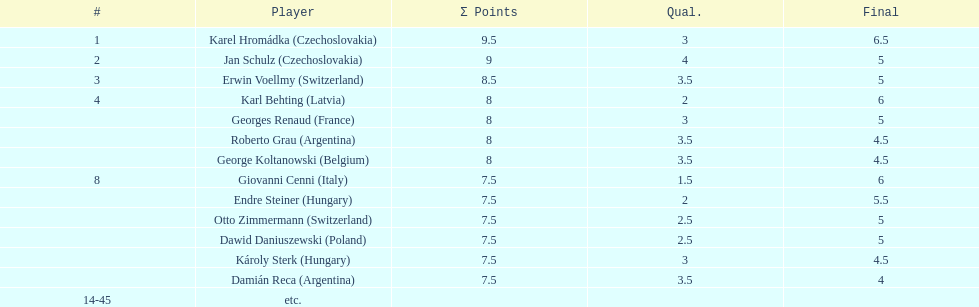What were the final scores of karl behting and giovanni cenni each? 6. Can you give me this table as a dict? {'header': ['#', 'Player', 'Σ Points', 'Qual.', 'Final'], 'rows': [['1', 'Karel Hromádka\xa0(Czechoslovakia)', '9.5', '3', '6.5'], ['2', 'Jan Schulz\xa0(Czechoslovakia)', '9', '4', '5'], ['3', 'Erwin Voellmy\xa0(Switzerland)', '8.5', '3.5', '5'], ['4', 'Karl Behting\xa0(Latvia)', '8', '2', '6'], ['', 'Georges Renaud\xa0(France)', '8', '3', '5'], ['', 'Roberto Grau\xa0(Argentina)', '8', '3.5', '4.5'], ['', 'George Koltanowski\xa0(Belgium)', '8', '3.5', '4.5'], ['8', 'Giovanni Cenni\xa0(Italy)', '7.5', '1.5', '6'], ['', 'Endre Steiner\xa0(Hungary)', '7.5', '2', '5.5'], ['', 'Otto Zimmermann\xa0(Switzerland)', '7.5', '2.5', '5'], ['', 'Dawid Daniuszewski\xa0(Poland)', '7.5', '2.5', '5'], ['', 'Károly Sterk\xa0(Hungary)', '7.5', '3', '4.5'], ['', 'Damián Reca\xa0(Argentina)', '7.5', '3.5', '4'], ['14-45', 'etc.', '', '', '']]} 